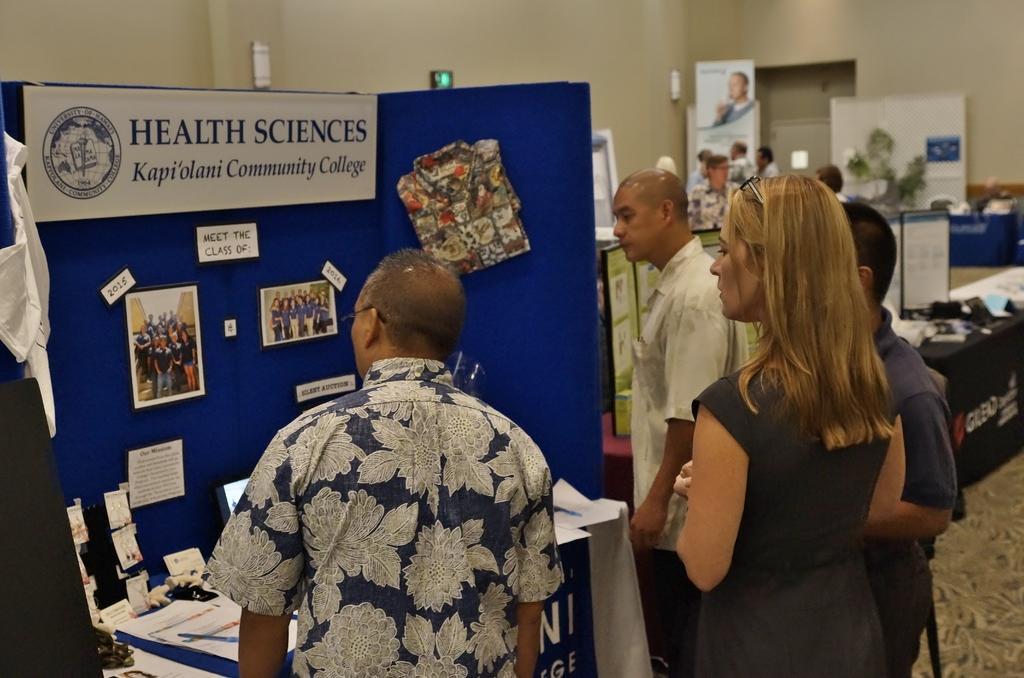Please provide a concise description of this image. This is the picture of a room in which there are some people standing in front of the table on which there are some things and a board on which there are some papers and posters and to the side there is a other table on which there are some things and some posters to the walls. 